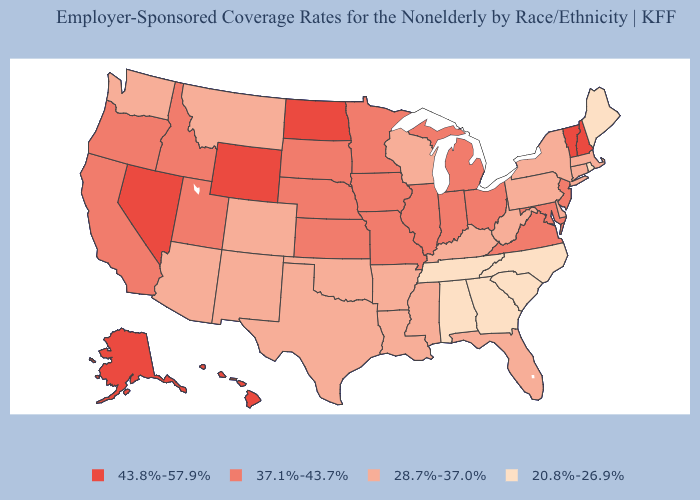What is the lowest value in states that border Mississippi?
Keep it brief. 20.8%-26.9%. Which states hav the highest value in the South?
Write a very short answer. Maryland, Virginia. What is the value of Alaska?
Concise answer only. 43.8%-57.9%. Does New York have a lower value than Montana?
Be succinct. No. What is the value of Maryland?
Answer briefly. 37.1%-43.7%. What is the value of Texas?
Answer briefly. 28.7%-37.0%. What is the highest value in the USA?
Give a very brief answer. 43.8%-57.9%. What is the value of Ohio?
Quick response, please. 37.1%-43.7%. Does Nevada have the highest value in the USA?
Quick response, please. Yes. Among the states that border South Carolina , which have the lowest value?
Concise answer only. Georgia, North Carolina. What is the lowest value in the USA?
Concise answer only. 20.8%-26.9%. How many symbols are there in the legend?
Keep it brief. 4. Which states have the highest value in the USA?
Be succinct. Alaska, Hawaii, Nevada, New Hampshire, North Dakota, Vermont, Wyoming. Among the states that border Oklahoma , which have the lowest value?
Answer briefly. Arkansas, Colorado, New Mexico, Texas. Name the states that have a value in the range 37.1%-43.7%?
Write a very short answer. California, Idaho, Illinois, Indiana, Iowa, Kansas, Maryland, Michigan, Minnesota, Missouri, Nebraska, New Jersey, Ohio, Oregon, South Dakota, Utah, Virginia. 